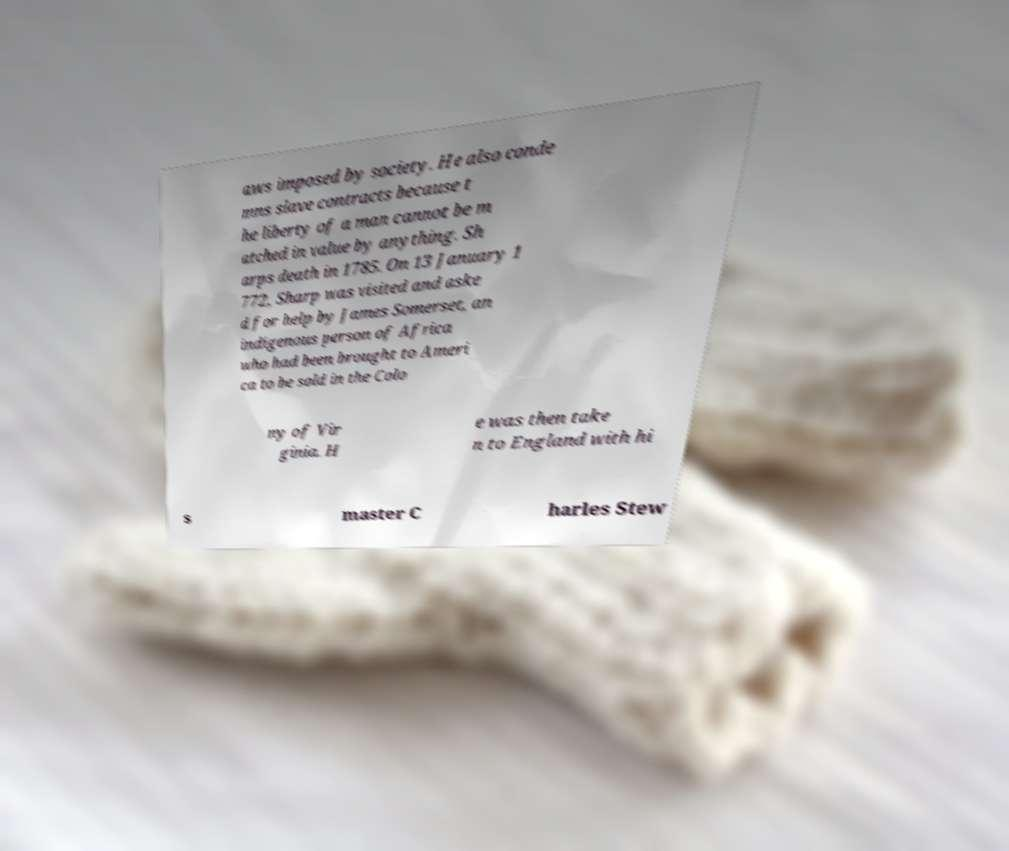For documentation purposes, I need the text within this image transcribed. Could you provide that? aws imposed by society. He also conde mns slave contracts because t he liberty of a man cannot be m atched in value by anything. Sh arps death in 1785. On 13 January 1 772, Sharp was visited and aske d for help by James Somerset, an indigenous person of Africa who had been brought to Ameri ca to be sold in the Colo ny of Vir ginia. H e was then take n to England with hi s master C harles Stew 